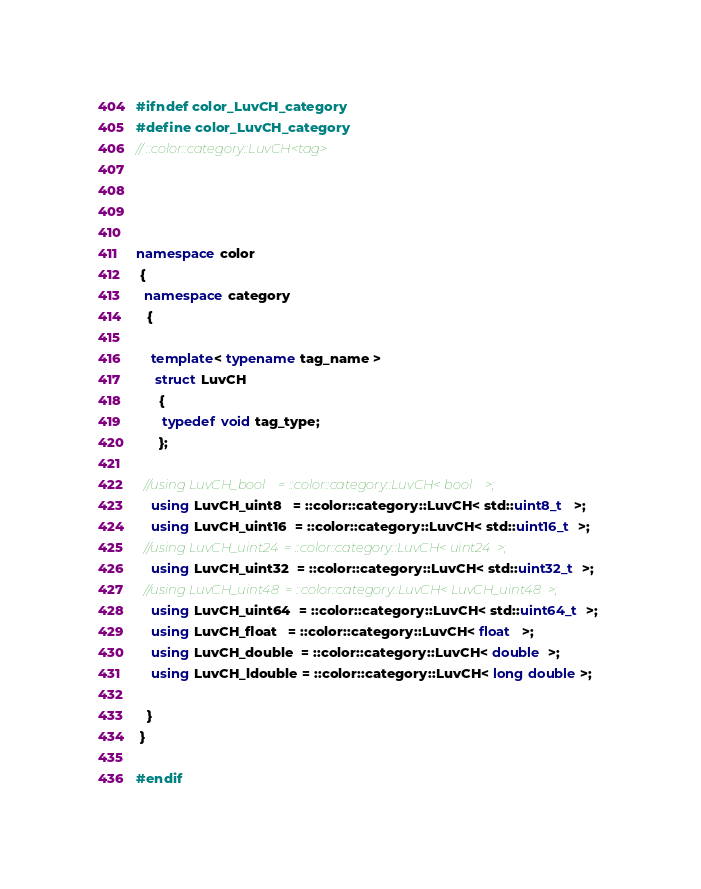Convert code to text. <code><loc_0><loc_0><loc_500><loc_500><_C++_>#ifndef color_LuvCH_category
#define color_LuvCH_category
// ::color::category::LuvCH<tag>




namespace color
 {
  namespace category
   {

    template< typename tag_name >
     struct LuvCH
      {
       typedef void tag_type;
      };

  //using LuvCH_bool    = ::color::category::LuvCH< bool    >;
    using LuvCH_uint8   = ::color::category::LuvCH< std::uint8_t   >;
    using LuvCH_uint16  = ::color::category::LuvCH< std::uint16_t  >;
  //using LuvCH_uint24  = ::color::category::LuvCH< uint24  >;
    using LuvCH_uint32  = ::color::category::LuvCH< std::uint32_t  >;
  //using LuvCH_uint48  = ::color::category::LuvCH< LuvCH_uint48  >;
    using LuvCH_uint64  = ::color::category::LuvCH< std::uint64_t  >;
    using LuvCH_float   = ::color::category::LuvCH< float   >;
    using LuvCH_double  = ::color::category::LuvCH< double  >;
    using LuvCH_ldouble = ::color::category::LuvCH< long double >;

   }
 }

#endif
</code> 